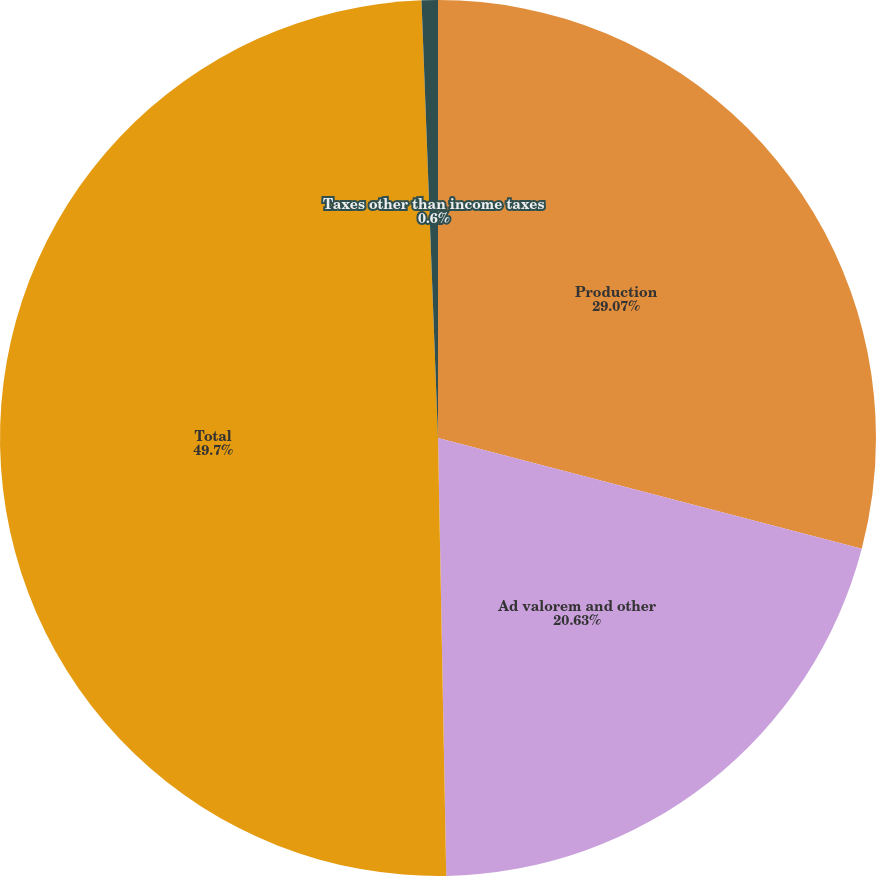Convert chart to OTSL. <chart><loc_0><loc_0><loc_500><loc_500><pie_chart><fcel>Production<fcel>Ad valorem and other<fcel>Total<fcel>Taxes other than income taxes<nl><fcel>29.07%<fcel>20.63%<fcel>49.7%<fcel>0.6%<nl></chart> 